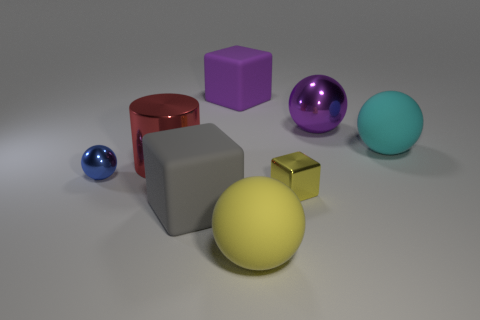What is the size of the blue metal thing?
Your response must be concise. Small. What number of gray things are the same size as the cyan thing?
Keep it short and to the point. 1. There is a purple thing that is the same shape as the big gray matte object; what material is it?
Provide a succinct answer. Rubber. What is the shape of the large object that is both on the right side of the large gray block and in front of the blue thing?
Make the answer very short. Sphere. What is the shape of the matte object that is to the right of the large purple metal thing?
Your response must be concise. Sphere. How many shiny objects are on the right side of the red shiny thing and on the left side of the yellow block?
Your response must be concise. 0. There is a blue shiny thing; is it the same size as the cube behind the tiny blue ball?
Keep it short and to the point. No. What size is the metal ball on the right side of the rubber ball that is on the left side of the ball right of the purple metallic sphere?
Provide a short and direct response. Large. How big is the metallic ball to the left of the big yellow matte thing?
Ensure brevity in your answer.  Small. What is the shape of the yellow thing that is the same material as the purple ball?
Keep it short and to the point. Cube. 